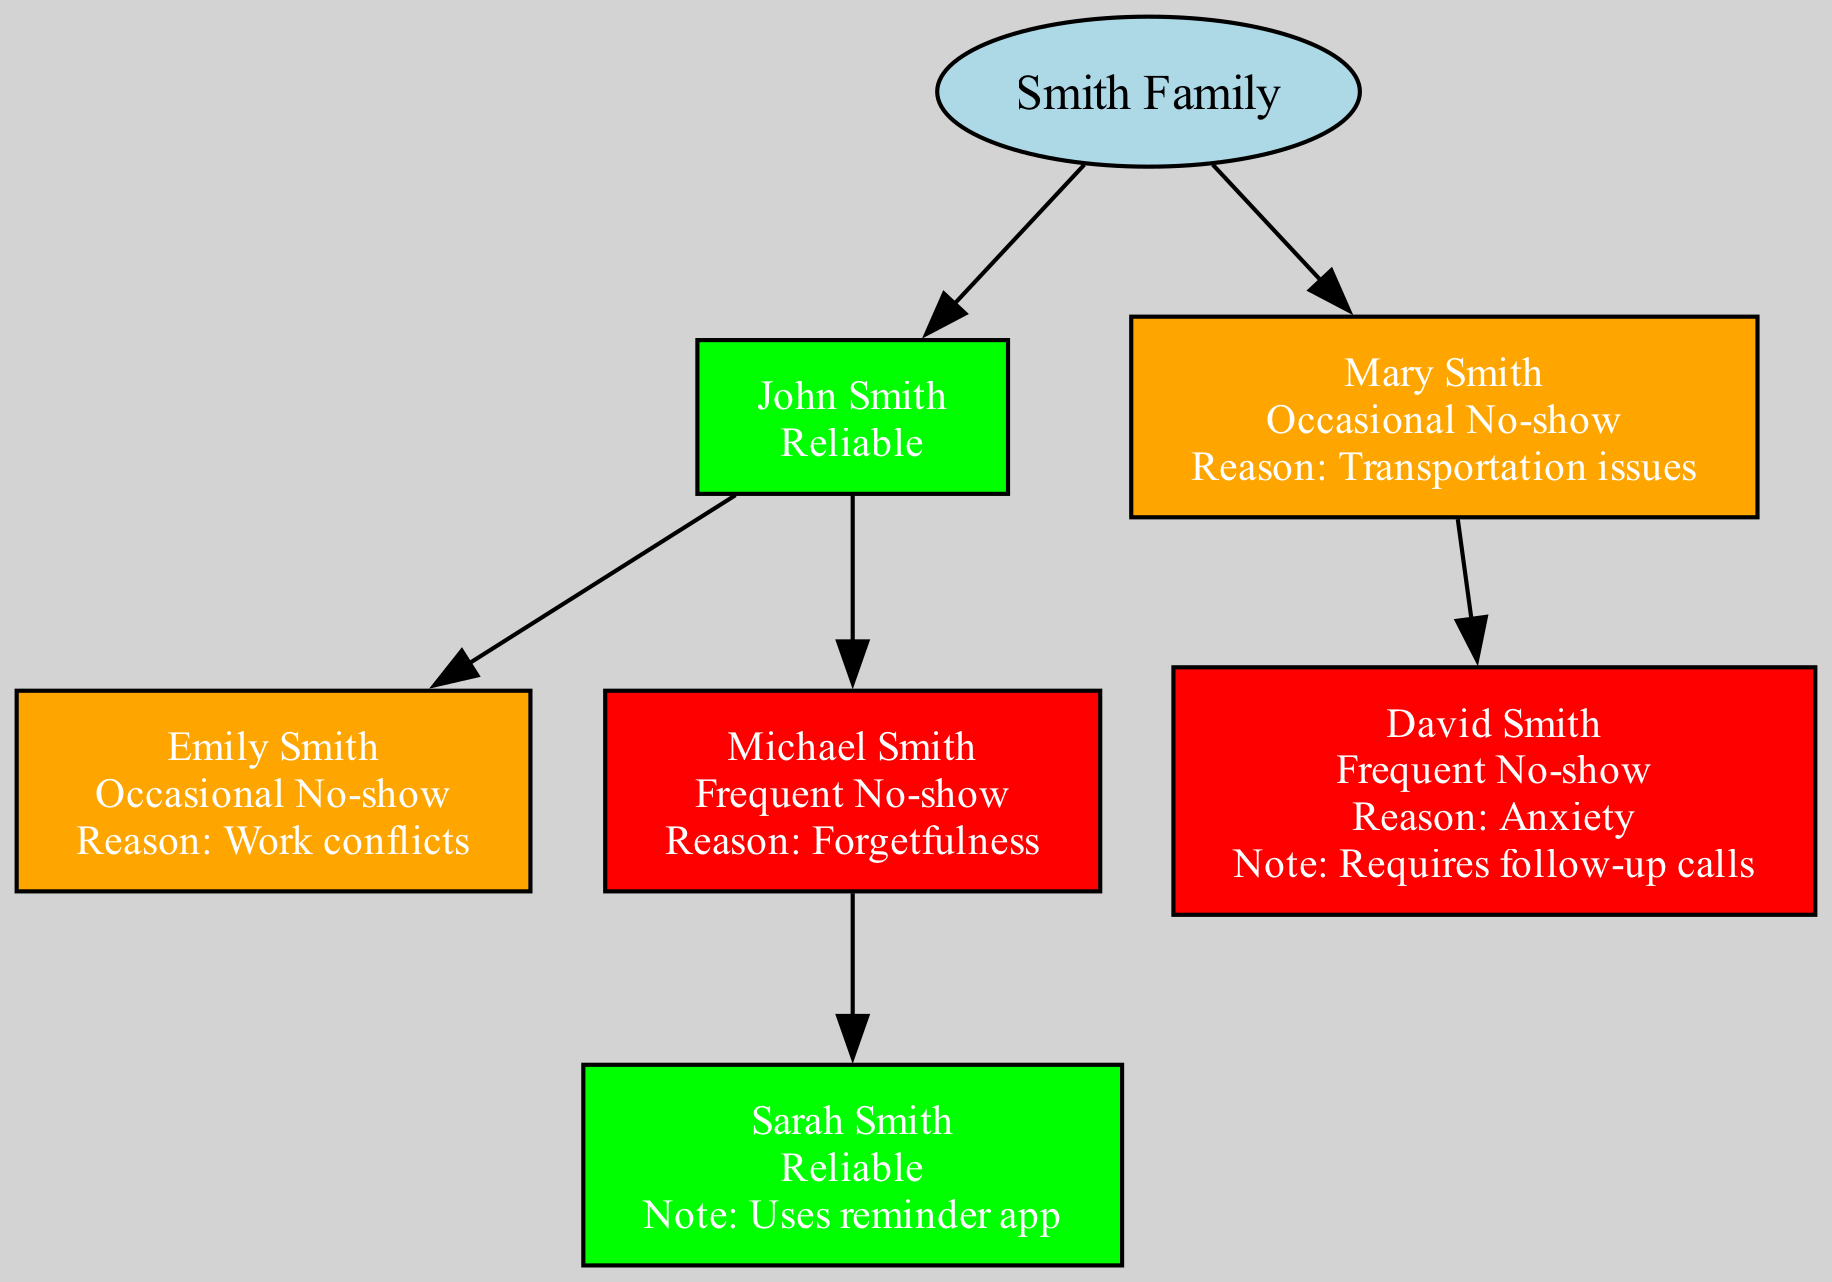What is the name of the root in the family tree? The root of the family tree is labeled as "Smith Family," which is indicated at the top of the diagram.
Answer: Smith Family How many children does John Smith have? By reviewing the section of the tree that pertains to John Smith, it is noted that he has two children: Emily Smith and Michael Smith.
Answer: 2 What is the status of Mary Smith? In the diagram, Mary's status is clearly indicated next to her name, showing that it is categorized as "Occasional No-show."
Answer: Occasional No-show What specific reason does Michael Smith have for frequently missing appointments? The diagram lists Michael Smith's reason for frequent no-shows as "Forgetfulness," which is specified right below his status.
Answer: Forgetfulness Which family member uses a reminder app? Upon examining the details in the child section under Michael Smith, it is noted that Sarah Smith is identified as "Reliable" and has a note stating she "Uses reminder app."
Answer: Sarah Smith How many total nodes are present in the family tree? The counting starts from the root node (Smith Family) and includes all branches, leading to a total of six individual nodes visible in the diagram: the root plus five named family members.
Answer: 6 Which member is in need of follow-up calls due to anxiety? The diagram indicates that David Smith has a status of "Frequent No-show" and has a note mentioning that he "Requires follow-up calls," which clarifies the individual's need.
Answer: David Smith Who is the most reliable member in the family tree? The diagram shows that both John Smith and Sarah Smith have the status of "Reliable." However, since the question asks for the one among them with the specific label, either could be correct, but John is a direct parent in the tree.
Answer: John Smith What is the transportation issue faced by Mary Smith? The family tree explicitly indicates that Mary Smith's reason for occasional no-shows is "Transportation issues," which is stated clearly alongside her status.
Answer: Transportation issues 